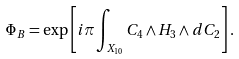<formula> <loc_0><loc_0><loc_500><loc_500>\Phi _ { B } = \exp \left [ i \pi \int _ { X _ { 1 0 } } C _ { 4 } \wedge H _ { 3 } \wedge d C _ { 2 } \right ] .</formula> 